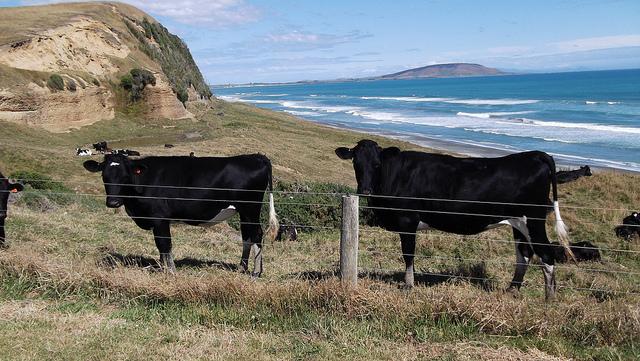What are these animals?
Keep it brief. Cows. Are all these animals the same species?
Keep it brief. Yes. Are these Hereford cows?
Concise answer only. Yes. How many fence posts do you see?
Quick response, please. 1. 